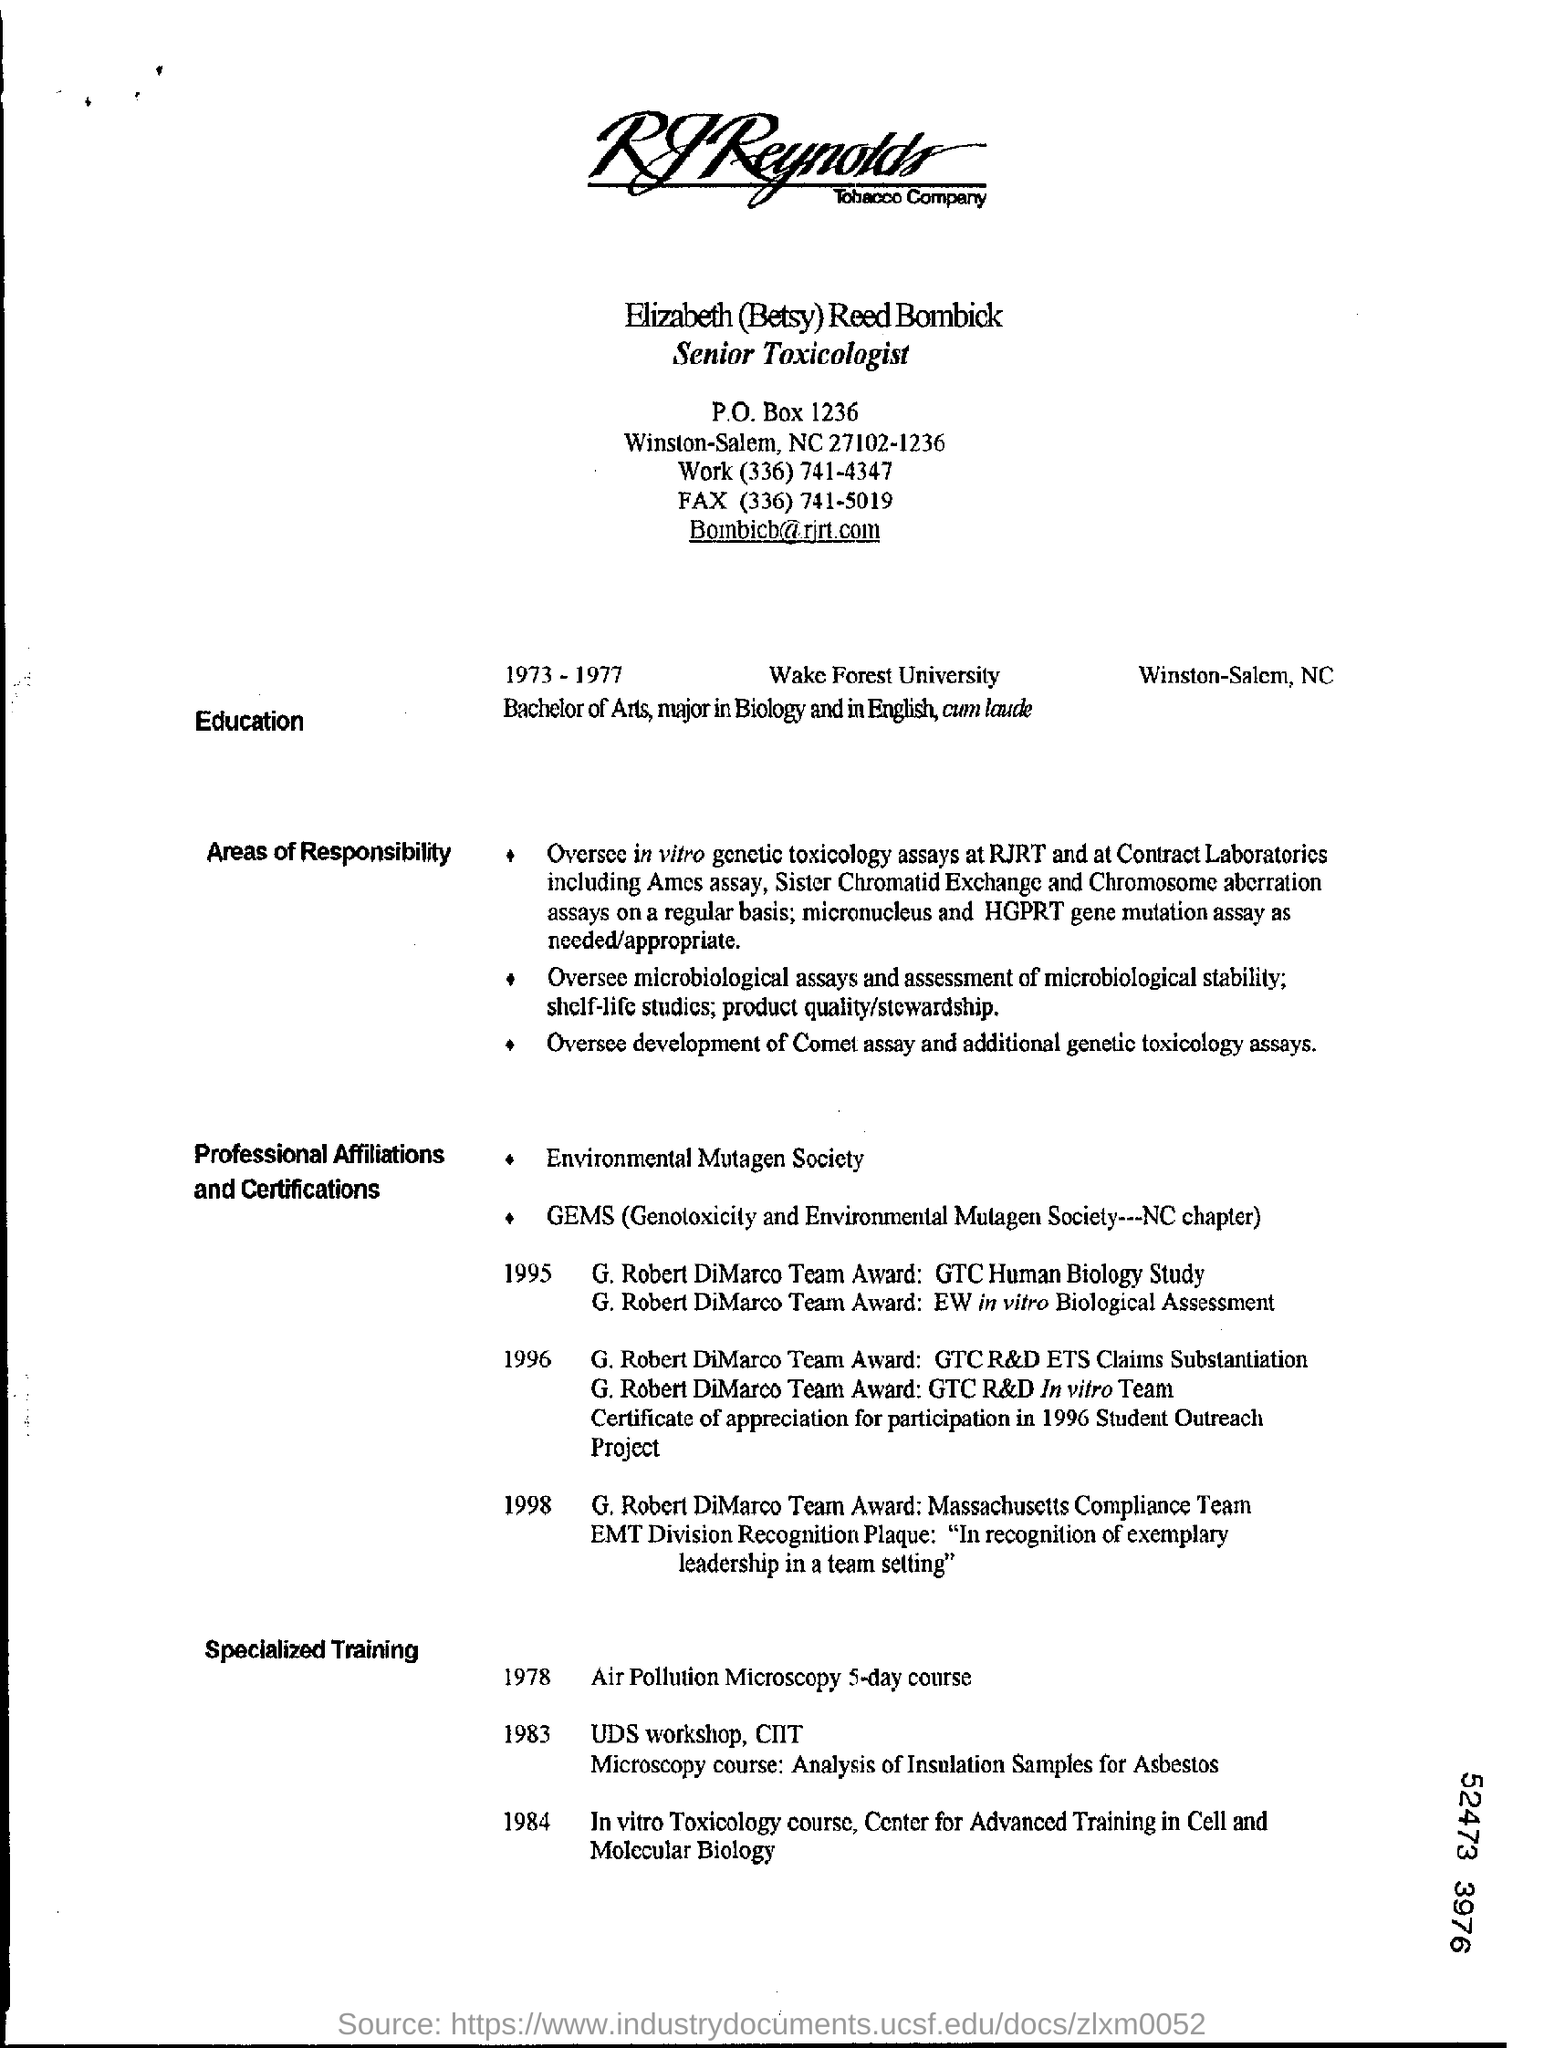What is the  P.O.Box no mentioned?
Your answer should be very brief. 1236. In 1978, Elizabeth (Betsy) Reed Bombick had specialized training in which course?
Your answer should be compact. Air pollution Microscopy 5-day course. In which year, Elizabeth (Betsy) Reed Bombick had specialized training In vitro Toxicology course?
Your response must be concise. 1984. 